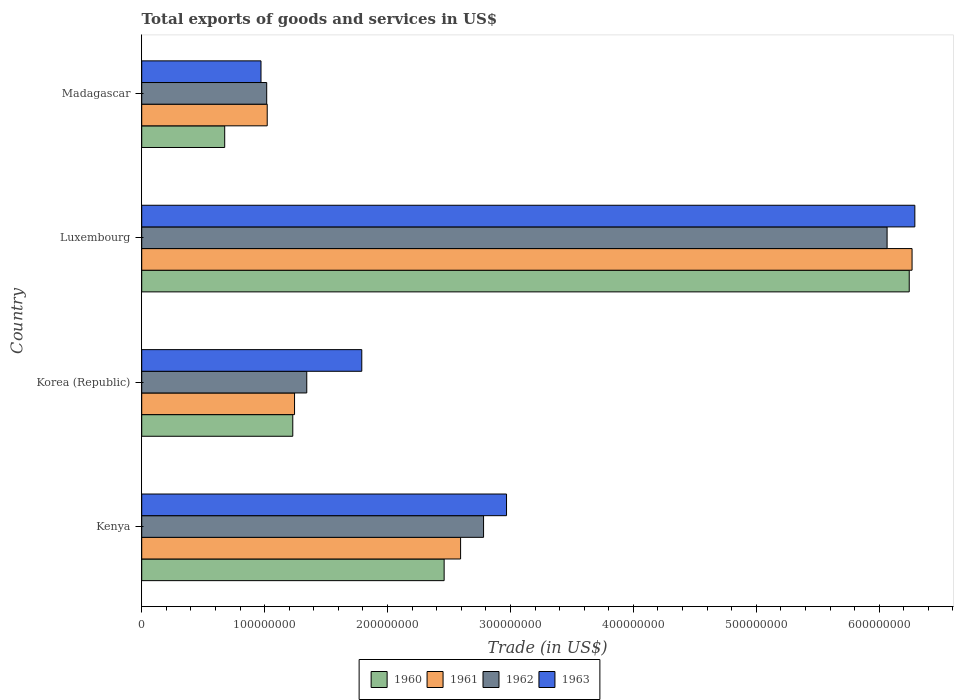What is the total exports of goods and services in 1962 in Korea (Republic)?
Ensure brevity in your answer.  1.34e+08. Across all countries, what is the maximum total exports of goods and services in 1961?
Offer a very short reply. 6.27e+08. Across all countries, what is the minimum total exports of goods and services in 1961?
Provide a succinct answer. 1.02e+08. In which country was the total exports of goods and services in 1961 maximum?
Provide a succinct answer. Luxembourg. In which country was the total exports of goods and services in 1961 minimum?
Provide a short and direct response. Madagascar. What is the total total exports of goods and services in 1960 in the graph?
Offer a very short reply. 1.06e+09. What is the difference between the total exports of goods and services in 1962 in Kenya and that in Korea (Republic)?
Your response must be concise. 1.44e+08. What is the difference between the total exports of goods and services in 1962 in Luxembourg and the total exports of goods and services in 1961 in Korea (Republic)?
Keep it short and to the point. 4.82e+08. What is the average total exports of goods and services in 1960 per country?
Your answer should be very brief. 2.65e+08. What is the difference between the total exports of goods and services in 1961 and total exports of goods and services in 1960 in Kenya?
Make the answer very short. 1.34e+07. What is the ratio of the total exports of goods and services in 1960 in Kenya to that in Madagascar?
Provide a succinct answer. 3.64. Is the difference between the total exports of goods and services in 1961 in Korea (Republic) and Madagascar greater than the difference between the total exports of goods and services in 1960 in Korea (Republic) and Madagascar?
Make the answer very short. No. What is the difference between the highest and the second highest total exports of goods and services in 1962?
Provide a succinct answer. 3.28e+08. What is the difference between the highest and the lowest total exports of goods and services in 1960?
Provide a succinct answer. 5.57e+08. Is the sum of the total exports of goods and services in 1960 in Luxembourg and Madagascar greater than the maximum total exports of goods and services in 1963 across all countries?
Provide a short and direct response. Yes. Is it the case that in every country, the sum of the total exports of goods and services in 1963 and total exports of goods and services in 1960 is greater than the sum of total exports of goods and services in 1962 and total exports of goods and services in 1961?
Offer a terse response. No. Is it the case that in every country, the sum of the total exports of goods and services in 1960 and total exports of goods and services in 1962 is greater than the total exports of goods and services in 1961?
Give a very brief answer. Yes. How many bars are there?
Make the answer very short. 16. How many countries are there in the graph?
Provide a short and direct response. 4. What is the difference between two consecutive major ticks on the X-axis?
Your answer should be very brief. 1.00e+08. Are the values on the major ticks of X-axis written in scientific E-notation?
Provide a short and direct response. No. How are the legend labels stacked?
Give a very brief answer. Horizontal. What is the title of the graph?
Provide a short and direct response. Total exports of goods and services in US$. Does "2007" appear as one of the legend labels in the graph?
Your answer should be very brief. No. What is the label or title of the X-axis?
Your answer should be compact. Trade (in US$). What is the Trade (in US$) of 1960 in Kenya?
Your answer should be compact. 2.46e+08. What is the Trade (in US$) in 1961 in Kenya?
Give a very brief answer. 2.59e+08. What is the Trade (in US$) in 1962 in Kenya?
Provide a short and direct response. 2.78e+08. What is the Trade (in US$) of 1963 in Kenya?
Make the answer very short. 2.97e+08. What is the Trade (in US$) of 1960 in Korea (Republic)?
Offer a terse response. 1.23e+08. What is the Trade (in US$) in 1961 in Korea (Republic)?
Your answer should be compact. 1.24e+08. What is the Trade (in US$) in 1962 in Korea (Republic)?
Offer a very short reply. 1.34e+08. What is the Trade (in US$) of 1963 in Korea (Republic)?
Provide a short and direct response. 1.79e+08. What is the Trade (in US$) in 1960 in Luxembourg?
Make the answer very short. 6.24e+08. What is the Trade (in US$) in 1961 in Luxembourg?
Your response must be concise. 6.27e+08. What is the Trade (in US$) of 1962 in Luxembourg?
Ensure brevity in your answer.  6.06e+08. What is the Trade (in US$) of 1963 in Luxembourg?
Offer a very short reply. 6.29e+08. What is the Trade (in US$) in 1960 in Madagascar?
Give a very brief answer. 6.75e+07. What is the Trade (in US$) in 1961 in Madagascar?
Make the answer very short. 1.02e+08. What is the Trade (in US$) of 1962 in Madagascar?
Keep it short and to the point. 1.02e+08. What is the Trade (in US$) of 1963 in Madagascar?
Your response must be concise. 9.70e+07. Across all countries, what is the maximum Trade (in US$) of 1960?
Your answer should be compact. 6.24e+08. Across all countries, what is the maximum Trade (in US$) in 1961?
Offer a very short reply. 6.27e+08. Across all countries, what is the maximum Trade (in US$) of 1962?
Your response must be concise. 6.06e+08. Across all countries, what is the maximum Trade (in US$) in 1963?
Ensure brevity in your answer.  6.29e+08. Across all countries, what is the minimum Trade (in US$) in 1960?
Your answer should be very brief. 6.75e+07. Across all countries, what is the minimum Trade (in US$) of 1961?
Your answer should be compact. 1.02e+08. Across all countries, what is the minimum Trade (in US$) of 1962?
Provide a succinct answer. 1.02e+08. Across all countries, what is the minimum Trade (in US$) of 1963?
Offer a terse response. 9.70e+07. What is the total Trade (in US$) in 1960 in the graph?
Provide a short and direct response. 1.06e+09. What is the total Trade (in US$) in 1961 in the graph?
Give a very brief answer. 1.11e+09. What is the total Trade (in US$) of 1962 in the graph?
Keep it short and to the point. 1.12e+09. What is the total Trade (in US$) in 1963 in the graph?
Your answer should be very brief. 1.20e+09. What is the difference between the Trade (in US$) of 1960 in Kenya and that in Korea (Republic)?
Ensure brevity in your answer.  1.23e+08. What is the difference between the Trade (in US$) of 1961 in Kenya and that in Korea (Republic)?
Your response must be concise. 1.35e+08. What is the difference between the Trade (in US$) of 1962 in Kenya and that in Korea (Republic)?
Your response must be concise. 1.44e+08. What is the difference between the Trade (in US$) of 1963 in Kenya and that in Korea (Republic)?
Your answer should be very brief. 1.18e+08. What is the difference between the Trade (in US$) of 1960 in Kenya and that in Luxembourg?
Provide a succinct answer. -3.78e+08. What is the difference between the Trade (in US$) of 1961 in Kenya and that in Luxembourg?
Your response must be concise. -3.67e+08. What is the difference between the Trade (in US$) in 1962 in Kenya and that in Luxembourg?
Keep it short and to the point. -3.28e+08. What is the difference between the Trade (in US$) in 1963 in Kenya and that in Luxembourg?
Your answer should be very brief. -3.32e+08. What is the difference between the Trade (in US$) of 1960 in Kenya and that in Madagascar?
Offer a very short reply. 1.79e+08. What is the difference between the Trade (in US$) of 1961 in Kenya and that in Madagascar?
Ensure brevity in your answer.  1.57e+08. What is the difference between the Trade (in US$) in 1962 in Kenya and that in Madagascar?
Keep it short and to the point. 1.76e+08. What is the difference between the Trade (in US$) in 1963 in Kenya and that in Madagascar?
Your answer should be very brief. 2.00e+08. What is the difference between the Trade (in US$) in 1960 in Korea (Republic) and that in Luxembourg?
Your response must be concise. -5.02e+08. What is the difference between the Trade (in US$) of 1961 in Korea (Republic) and that in Luxembourg?
Make the answer very short. -5.02e+08. What is the difference between the Trade (in US$) in 1962 in Korea (Republic) and that in Luxembourg?
Offer a terse response. -4.72e+08. What is the difference between the Trade (in US$) in 1963 in Korea (Republic) and that in Luxembourg?
Offer a very short reply. -4.50e+08. What is the difference between the Trade (in US$) of 1960 in Korea (Republic) and that in Madagascar?
Make the answer very short. 5.54e+07. What is the difference between the Trade (in US$) of 1961 in Korea (Republic) and that in Madagascar?
Give a very brief answer. 2.22e+07. What is the difference between the Trade (in US$) in 1962 in Korea (Republic) and that in Madagascar?
Your response must be concise. 3.26e+07. What is the difference between the Trade (in US$) in 1963 in Korea (Republic) and that in Madagascar?
Your response must be concise. 8.20e+07. What is the difference between the Trade (in US$) in 1960 in Luxembourg and that in Madagascar?
Ensure brevity in your answer.  5.57e+08. What is the difference between the Trade (in US$) in 1961 in Luxembourg and that in Madagascar?
Provide a succinct answer. 5.25e+08. What is the difference between the Trade (in US$) of 1962 in Luxembourg and that in Madagascar?
Your answer should be compact. 5.05e+08. What is the difference between the Trade (in US$) in 1963 in Luxembourg and that in Madagascar?
Ensure brevity in your answer.  5.32e+08. What is the difference between the Trade (in US$) in 1960 in Kenya and the Trade (in US$) in 1961 in Korea (Republic)?
Offer a very short reply. 1.22e+08. What is the difference between the Trade (in US$) in 1960 in Kenya and the Trade (in US$) in 1962 in Korea (Republic)?
Provide a short and direct response. 1.12e+08. What is the difference between the Trade (in US$) of 1960 in Kenya and the Trade (in US$) of 1963 in Korea (Republic)?
Your answer should be compact. 6.70e+07. What is the difference between the Trade (in US$) in 1961 in Kenya and the Trade (in US$) in 1962 in Korea (Republic)?
Your answer should be compact. 1.25e+08. What is the difference between the Trade (in US$) in 1961 in Kenya and the Trade (in US$) in 1963 in Korea (Republic)?
Provide a short and direct response. 8.04e+07. What is the difference between the Trade (in US$) in 1962 in Kenya and the Trade (in US$) in 1963 in Korea (Republic)?
Keep it short and to the point. 9.91e+07. What is the difference between the Trade (in US$) in 1960 in Kenya and the Trade (in US$) in 1961 in Luxembourg?
Your response must be concise. -3.81e+08. What is the difference between the Trade (in US$) in 1960 in Kenya and the Trade (in US$) in 1962 in Luxembourg?
Provide a short and direct response. -3.60e+08. What is the difference between the Trade (in US$) of 1960 in Kenya and the Trade (in US$) of 1963 in Luxembourg?
Your response must be concise. -3.83e+08. What is the difference between the Trade (in US$) of 1961 in Kenya and the Trade (in US$) of 1962 in Luxembourg?
Your response must be concise. -3.47e+08. What is the difference between the Trade (in US$) in 1961 in Kenya and the Trade (in US$) in 1963 in Luxembourg?
Make the answer very short. -3.70e+08. What is the difference between the Trade (in US$) of 1962 in Kenya and the Trade (in US$) of 1963 in Luxembourg?
Offer a terse response. -3.51e+08. What is the difference between the Trade (in US$) of 1960 in Kenya and the Trade (in US$) of 1961 in Madagascar?
Your answer should be very brief. 1.44e+08. What is the difference between the Trade (in US$) in 1960 in Kenya and the Trade (in US$) in 1962 in Madagascar?
Your answer should be compact. 1.44e+08. What is the difference between the Trade (in US$) of 1960 in Kenya and the Trade (in US$) of 1963 in Madagascar?
Ensure brevity in your answer.  1.49e+08. What is the difference between the Trade (in US$) of 1961 in Kenya and the Trade (in US$) of 1962 in Madagascar?
Offer a terse response. 1.58e+08. What is the difference between the Trade (in US$) in 1961 in Kenya and the Trade (in US$) in 1963 in Madagascar?
Provide a short and direct response. 1.62e+08. What is the difference between the Trade (in US$) in 1962 in Kenya and the Trade (in US$) in 1963 in Madagascar?
Your answer should be compact. 1.81e+08. What is the difference between the Trade (in US$) in 1960 in Korea (Republic) and the Trade (in US$) in 1961 in Luxembourg?
Offer a very short reply. -5.04e+08. What is the difference between the Trade (in US$) of 1960 in Korea (Republic) and the Trade (in US$) of 1962 in Luxembourg?
Offer a very short reply. -4.84e+08. What is the difference between the Trade (in US$) in 1960 in Korea (Republic) and the Trade (in US$) in 1963 in Luxembourg?
Make the answer very short. -5.06e+08. What is the difference between the Trade (in US$) in 1961 in Korea (Republic) and the Trade (in US$) in 1962 in Luxembourg?
Your answer should be very brief. -4.82e+08. What is the difference between the Trade (in US$) of 1961 in Korea (Republic) and the Trade (in US$) of 1963 in Luxembourg?
Make the answer very short. -5.05e+08. What is the difference between the Trade (in US$) in 1962 in Korea (Republic) and the Trade (in US$) in 1963 in Luxembourg?
Provide a succinct answer. -4.95e+08. What is the difference between the Trade (in US$) in 1960 in Korea (Republic) and the Trade (in US$) in 1961 in Madagascar?
Make the answer very short. 2.08e+07. What is the difference between the Trade (in US$) of 1960 in Korea (Republic) and the Trade (in US$) of 1962 in Madagascar?
Keep it short and to the point. 2.12e+07. What is the difference between the Trade (in US$) of 1960 in Korea (Republic) and the Trade (in US$) of 1963 in Madagascar?
Your answer should be compact. 2.59e+07. What is the difference between the Trade (in US$) in 1961 in Korea (Republic) and the Trade (in US$) in 1962 in Madagascar?
Your answer should be compact. 2.27e+07. What is the difference between the Trade (in US$) in 1961 in Korea (Republic) and the Trade (in US$) in 1963 in Madagascar?
Provide a short and direct response. 2.73e+07. What is the difference between the Trade (in US$) of 1962 in Korea (Republic) and the Trade (in US$) of 1963 in Madagascar?
Offer a terse response. 3.72e+07. What is the difference between the Trade (in US$) of 1960 in Luxembourg and the Trade (in US$) of 1961 in Madagascar?
Your answer should be very brief. 5.22e+08. What is the difference between the Trade (in US$) in 1960 in Luxembourg and the Trade (in US$) in 1962 in Madagascar?
Ensure brevity in your answer.  5.23e+08. What is the difference between the Trade (in US$) of 1960 in Luxembourg and the Trade (in US$) of 1963 in Madagascar?
Offer a very short reply. 5.27e+08. What is the difference between the Trade (in US$) in 1961 in Luxembourg and the Trade (in US$) in 1962 in Madagascar?
Offer a very short reply. 5.25e+08. What is the difference between the Trade (in US$) in 1961 in Luxembourg and the Trade (in US$) in 1963 in Madagascar?
Offer a very short reply. 5.30e+08. What is the difference between the Trade (in US$) of 1962 in Luxembourg and the Trade (in US$) of 1963 in Madagascar?
Give a very brief answer. 5.09e+08. What is the average Trade (in US$) of 1960 per country?
Make the answer very short. 2.65e+08. What is the average Trade (in US$) in 1961 per country?
Make the answer very short. 2.78e+08. What is the average Trade (in US$) in 1962 per country?
Offer a terse response. 2.80e+08. What is the average Trade (in US$) in 1963 per country?
Provide a succinct answer. 3.00e+08. What is the difference between the Trade (in US$) of 1960 and Trade (in US$) of 1961 in Kenya?
Your answer should be compact. -1.34e+07. What is the difference between the Trade (in US$) in 1960 and Trade (in US$) in 1962 in Kenya?
Your answer should be very brief. -3.21e+07. What is the difference between the Trade (in US$) of 1960 and Trade (in US$) of 1963 in Kenya?
Ensure brevity in your answer.  -5.08e+07. What is the difference between the Trade (in US$) of 1961 and Trade (in US$) of 1962 in Kenya?
Your answer should be very brief. -1.87e+07. What is the difference between the Trade (in US$) in 1961 and Trade (in US$) in 1963 in Kenya?
Make the answer very short. -3.74e+07. What is the difference between the Trade (in US$) in 1962 and Trade (in US$) in 1963 in Kenya?
Provide a succinct answer. -1.87e+07. What is the difference between the Trade (in US$) of 1960 and Trade (in US$) of 1961 in Korea (Republic)?
Make the answer very short. -1.44e+06. What is the difference between the Trade (in US$) in 1960 and Trade (in US$) in 1962 in Korea (Republic)?
Your answer should be compact. -1.14e+07. What is the difference between the Trade (in US$) in 1960 and Trade (in US$) in 1963 in Korea (Republic)?
Keep it short and to the point. -5.61e+07. What is the difference between the Trade (in US$) in 1961 and Trade (in US$) in 1962 in Korea (Republic)?
Offer a terse response. -9.94e+06. What is the difference between the Trade (in US$) of 1961 and Trade (in US$) of 1963 in Korea (Republic)?
Keep it short and to the point. -5.47e+07. What is the difference between the Trade (in US$) in 1962 and Trade (in US$) in 1963 in Korea (Republic)?
Keep it short and to the point. -4.48e+07. What is the difference between the Trade (in US$) of 1960 and Trade (in US$) of 1961 in Luxembourg?
Your response must be concise. -2.31e+06. What is the difference between the Trade (in US$) of 1960 and Trade (in US$) of 1962 in Luxembourg?
Provide a succinct answer. 1.80e+07. What is the difference between the Trade (in US$) of 1960 and Trade (in US$) of 1963 in Luxembourg?
Your response must be concise. -4.56e+06. What is the difference between the Trade (in US$) in 1961 and Trade (in US$) in 1962 in Luxembourg?
Your answer should be compact. 2.03e+07. What is the difference between the Trade (in US$) of 1961 and Trade (in US$) of 1963 in Luxembourg?
Make the answer very short. -2.25e+06. What is the difference between the Trade (in US$) in 1962 and Trade (in US$) in 1963 in Luxembourg?
Provide a short and direct response. -2.26e+07. What is the difference between the Trade (in US$) in 1960 and Trade (in US$) in 1961 in Madagascar?
Your answer should be compact. -3.46e+07. What is the difference between the Trade (in US$) in 1960 and Trade (in US$) in 1962 in Madagascar?
Provide a succinct answer. -3.42e+07. What is the difference between the Trade (in US$) of 1960 and Trade (in US$) of 1963 in Madagascar?
Your response must be concise. -2.95e+07. What is the difference between the Trade (in US$) in 1961 and Trade (in US$) in 1962 in Madagascar?
Your answer should be compact. 4.22e+05. What is the difference between the Trade (in US$) in 1961 and Trade (in US$) in 1963 in Madagascar?
Make the answer very short. 5.06e+06. What is the difference between the Trade (in US$) in 1962 and Trade (in US$) in 1963 in Madagascar?
Give a very brief answer. 4.64e+06. What is the ratio of the Trade (in US$) of 1960 in Kenya to that in Korea (Republic)?
Your answer should be compact. 2. What is the ratio of the Trade (in US$) in 1961 in Kenya to that in Korea (Republic)?
Provide a short and direct response. 2.09. What is the ratio of the Trade (in US$) of 1962 in Kenya to that in Korea (Republic)?
Provide a succinct answer. 2.07. What is the ratio of the Trade (in US$) in 1963 in Kenya to that in Korea (Republic)?
Make the answer very short. 1.66. What is the ratio of the Trade (in US$) of 1960 in Kenya to that in Luxembourg?
Provide a succinct answer. 0.39. What is the ratio of the Trade (in US$) in 1961 in Kenya to that in Luxembourg?
Offer a very short reply. 0.41. What is the ratio of the Trade (in US$) of 1962 in Kenya to that in Luxembourg?
Provide a short and direct response. 0.46. What is the ratio of the Trade (in US$) in 1963 in Kenya to that in Luxembourg?
Provide a succinct answer. 0.47. What is the ratio of the Trade (in US$) in 1960 in Kenya to that in Madagascar?
Make the answer very short. 3.64. What is the ratio of the Trade (in US$) of 1961 in Kenya to that in Madagascar?
Provide a succinct answer. 2.54. What is the ratio of the Trade (in US$) in 1962 in Kenya to that in Madagascar?
Your answer should be very brief. 2.73. What is the ratio of the Trade (in US$) of 1963 in Kenya to that in Madagascar?
Offer a terse response. 3.06. What is the ratio of the Trade (in US$) in 1960 in Korea (Republic) to that in Luxembourg?
Offer a very short reply. 0.2. What is the ratio of the Trade (in US$) in 1961 in Korea (Republic) to that in Luxembourg?
Your response must be concise. 0.2. What is the ratio of the Trade (in US$) in 1962 in Korea (Republic) to that in Luxembourg?
Make the answer very short. 0.22. What is the ratio of the Trade (in US$) of 1963 in Korea (Republic) to that in Luxembourg?
Offer a terse response. 0.28. What is the ratio of the Trade (in US$) in 1960 in Korea (Republic) to that in Madagascar?
Provide a succinct answer. 1.82. What is the ratio of the Trade (in US$) in 1961 in Korea (Republic) to that in Madagascar?
Offer a terse response. 1.22. What is the ratio of the Trade (in US$) in 1962 in Korea (Republic) to that in Madagascar?
Provide a short and direct response. 1.32. What is the ratio of the Trade (in US$) of 1963 in Korea (Republic) to that in Madagascar?
Provide a short and direct response. 1.84. What is the ratio of the Trade (in US$) in 1960 in Luxembourg to that in Madagascar?
Make the answer very short. 9.25. What is the ratio of the Trade (in US$) of 1961 in Luxembourg to that in Madagascar?
Your answer should be very brief. 6.14. What is the ratio of the Trade (in US$) of 1962 in Luxembourg to that in Madagascar?
Give a very brief answer. 5.96. What is the ratio of the Trade (in US$) in 1963 in Luxembourg to that in Madagascar?
Offer a terse response. 6.48. What is the difference between the highest and the second highest Trade (in US$) of 1960?
Your answer should be very brief. 3.78e+08. What is the difference between the highest and the second highest Trade (in US$) in 1961?
Provide a short and direct response. 3.67e+08. What is the difference between the highest and the second highest Trade (in US$) of 1962?
Provide a short and direct response. 3.28e+08. What is the difference between the highest and the second highest Trade (in US$) in 1963?
Provide a succinct answer. 3.32e+08. What is the difference between the highest and the lowest Trade (in US$) in 1960?
Keep it short and to the point. 5.57e+08. What is the difference between the highest and the lowest Trade (in US$) of 1961?
Offer a terse response. 5.25e+08. What is the difference between the highest and the lowest Trade (in US$) in 1962?
Your answer should be very brief. 5.05e+08. What is the difference between the highest and the lowest Trade (in US$) of 1963?
Your answer should be very brief. 5.32e+08. 